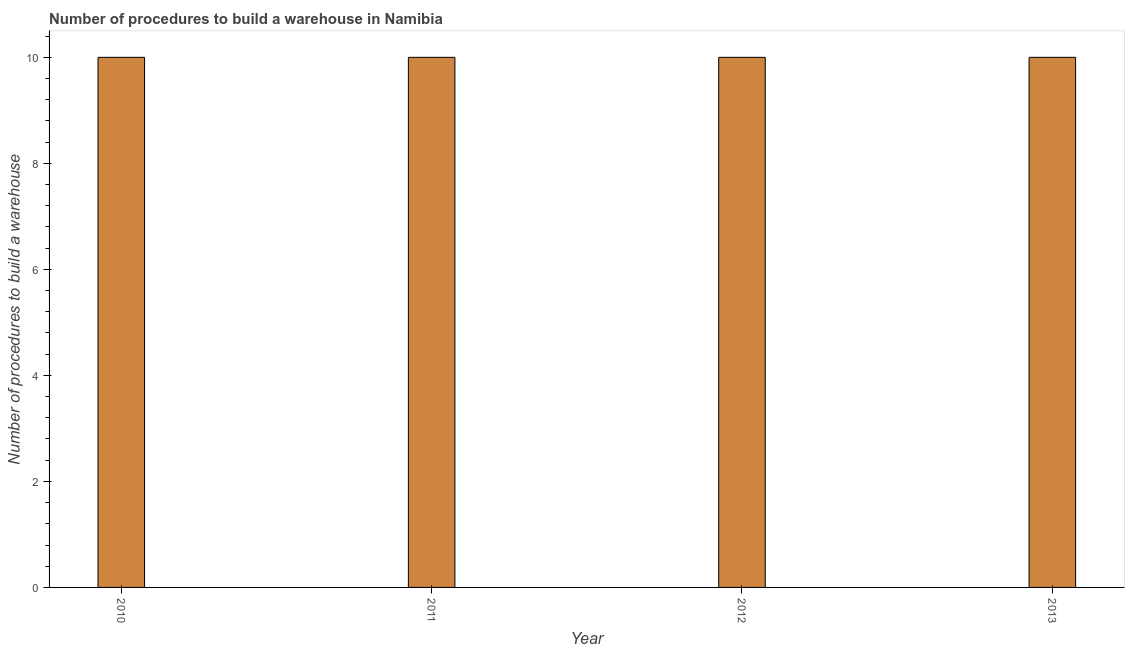What is the title of the graph?
Give a very brief answer. Number of procedures to build a warehouse in Namibia. What is the label or title of the X-axis?
Your response must be concise. Year. What is the label or title of the Y-axis?
Offer a terse response. Number of procedures to build a warehouse. What is the number of procedures to build a warehouse in 2011?
Give a very brief answer. 10. Across all years, what is the minimum number of procedures to build a warehouse?
Your answer should be very brief. 10. What is the average number of procedures to build a warehouse per year?
Provide a succinct answer. 10. In how many years, is the number of procedures to build a warehouse greater than 4.8 ?
Provide a succinct answer. 4. Do a majority of the years between 2010 and 2013 (inclusive) have number of procedures to build a warehouse greater than 8.4 ?
Offer a very short reply. Yes. Is the number of procedures to build a warehouse in 2011 less than that in 2013?
Make the answer very short. No. Is the sum of the number of procedures to build a warehouse in 2011 and 2013 greater than the maximum number of procedures to build a warehouse across all years?
Your answer should be compact. Yes. Are all the bars in the graph horizontal?
Your answer should be compact. No. What is the Number of procedures to build a warehouse of 2010?
Make the answer very short. 10. What is the Number of procedures to build a warehouse of 2011?
Provide a short and direct response. 10. What is the Number of procedures to build a warehouse of 2012?
Provide a short and direct response. 10. What is the Number of procedures to build a warehouse of 2013?
Provide a succinct answer. 10. What is the difference between the Number of procedures to build a warehouse in 2010 and 2013?
Offer a terse response. 0. What is the difference between the Number of procedures to build a warehouse in 2011 and 2013?
Keep it short and to the point. 0. What is the ratio of the Number of procedures to build a warehouse in 2010 to that in 2011?
Offer a very short reply. 1. What is the ratio of the Number of procedures to build a warehouse in 2010 to that in 2013?
Offer a terse response. 1. 